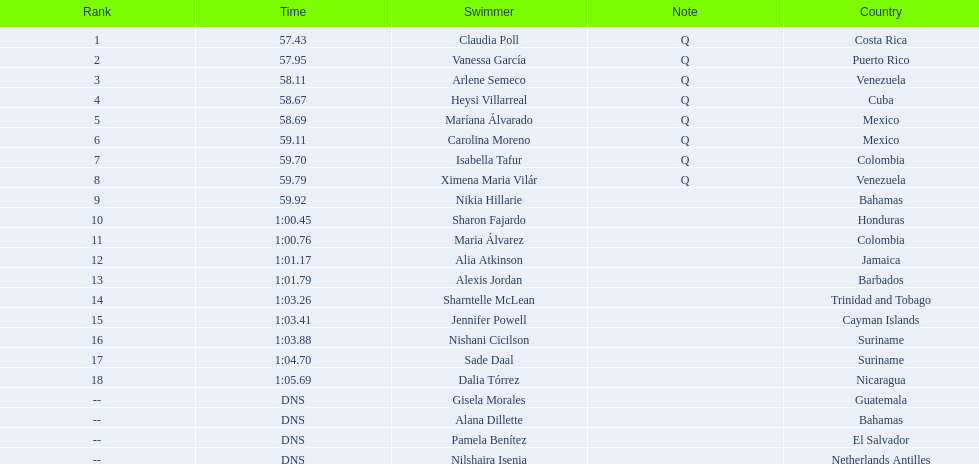How many swimmers are from mexico? 2. 